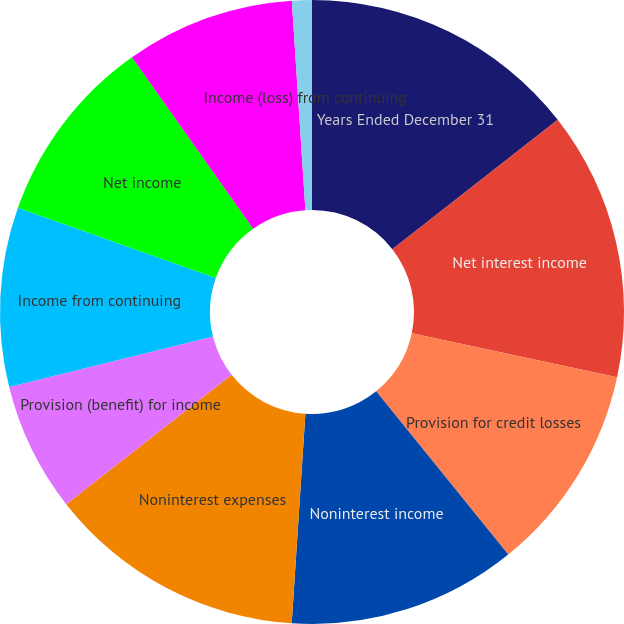<chart> <loc_0><loc_0><loc_500><loc_500><pie_chart><fcel>Years Ended December 31<fcel>Net interest income<fcel>Provision for credit losses<fcel>Noninterest income<fcel>Noninterest expenses<fcel>Provision (benefit) for income<fcel>Income from continuing<fcel>Net income<fcel>Net income (loss) attributable<fcel>Income (loss) from continuing<nl><fcel>14.43%<fcel>13.92%<fcel>10.82%<fcel>11.86%<fcel>13.4%<fcel>6.7%<fcel>9.28%<fcel>9.79%<fcel>8.76%<fcel>1.03%<nl></chart> 